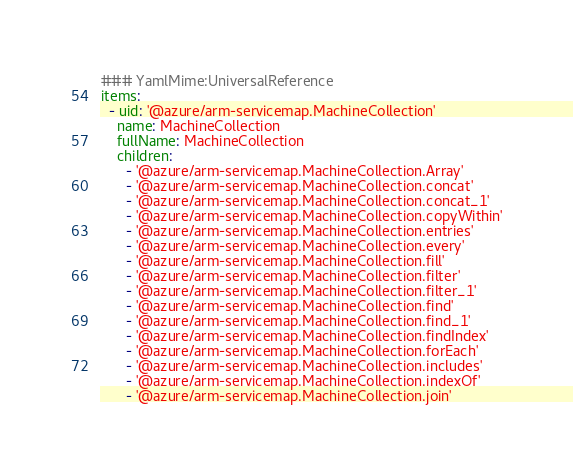<code> <loc_0><loc_0><loc_500><loc_500><_YAML_>### YamlMime:UniversalReference
items:
  - uid: '@azure/arm-servicemap.MachineCollection'
    name: MachineCollection
    fullName: MachineCollection
    children:
      - '@azure/arm-servicemap.MachineCollection.Array'
      - '@azure/arm-servicemap.MachineCollection.concat'
      - '@azure/arm-servicemap.MachineCollection.concat_1'
      - '@azure/arm-servicemap.MachineCollection.copyWithin'
      - '@azure/arm-servicemap.MachineCollection.entries'
      - '@azure/arm-servicemap.MachineCollection.every'
      - '@azure/arm-servicemap.MachineCollection.fill'
      - '@azure/arm-servicemap.MachineCollection.filter'
      - '@azure/arm-servicemap.MachineCollection.filter_1'
      - '@azure/arm-servicemap.MachineCollection.find'
      - '@azure/arm-servicemap.MachineCollection.find_1'
      - '@azure/arm-servicemap.MachineCollection.findIndex'
      - '@azure/arm-servicemap.MachineCollection.forEach'
      - '@azure/arm-servicemap.MachineCollection.includes'
      - '@azure/arm-servicemap.MachineCollection.indexOf'
      - '@azure/arm-servicemap.MachineCollection.join'</code> 